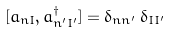Convert formula to latex. <formula><loc_0><loc_0><loc_500><loc_500>[ a _ { n I } , a _ { n ^ { \prime } I ^ { \prime } } ^ { \dagger } ] = \delta _ { n n ^ { \prime } } \, \delta _ { I I ^ { \prime } }</formula> 